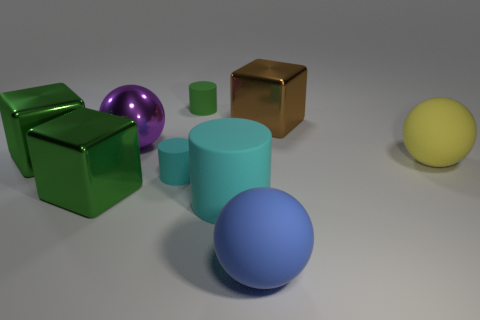There is a matte ball that is to the right of the large metallic cube to the right of the tiny green cylinder; what color is it?
Your answer should be very brief. Yellow. What number of other objects are there of the same material as the large brown block?
Your response must be concise. 3. What number of other things are there of the same color as the large rubber cylinder?
Make the answer very short. 1. What is the material of the large block that is behind the big green metallic block that is behind the small cyan matte cylinder?
Offer a very short reply. Metal. Is there a small purple shiny sphere?
Ensure brevity in your answer.  No. What size is the brown metallic cube to the right of the small matte thing that is in front of the yellow thing?
Your answer should be compact. Large. Are there more cyan rubber objects in front of the tiny cyan rubber cylinder than green things in front of the brown object?
Give a very brief answer. No. How many cylinders are either small green objects or large yellow rubber objects?
Your response must be concise. 1. Are there any other things that have the same size as the shiny ball?
Make the answer very short. Yes. There is a metallic object in front of the yellow matte thing; does it have the same shape as the big cyan matte object?
Offer a terse response. No. 